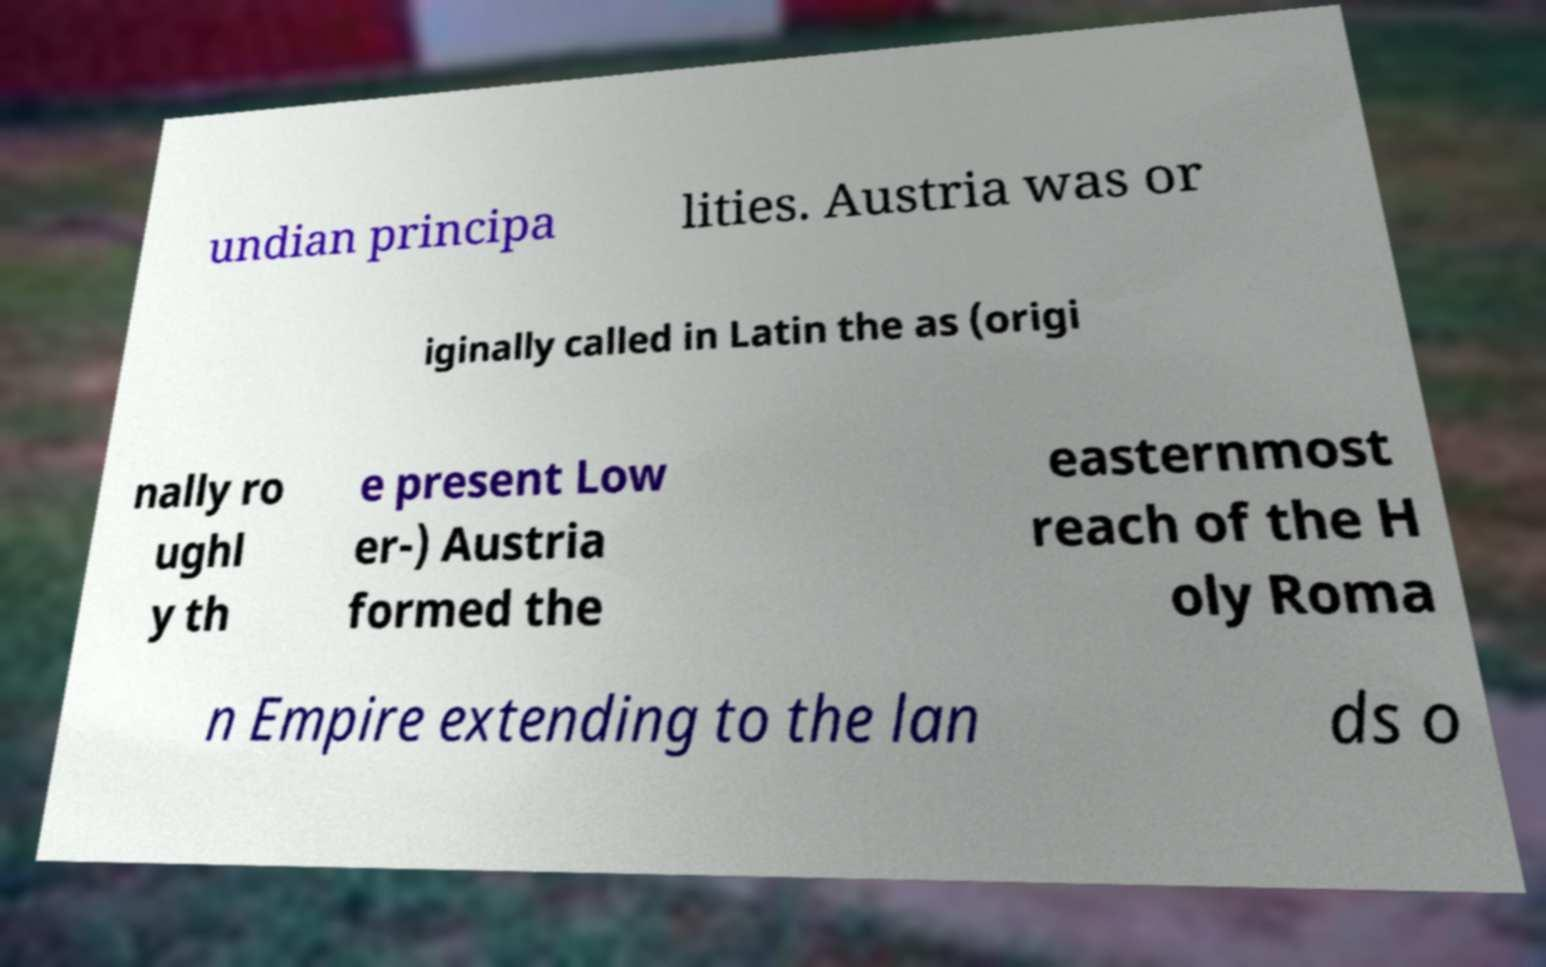Please identify and transcribe the text found in this image. undian principa lities. Austria was or iginally called in Latin the as (origi nally ro ughl y th e present Low er-) Austria formed the easternmost reach of the H oly Roma n Empire extending to the lan ds o 